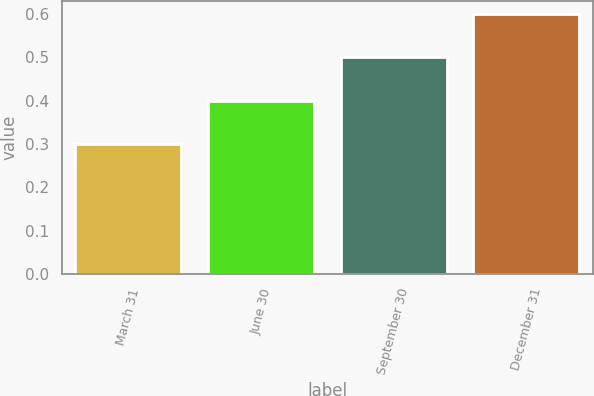<chart> <loc_0><loc_0><loc_500><loc_500><bar_chart><fcel>March 31<fcel>June 30<fcel>September 30<fcel>December 31<nl><fcel>0.3<fcel>0.4<fcel>0.5<fcel>0.6<nl></chart> 